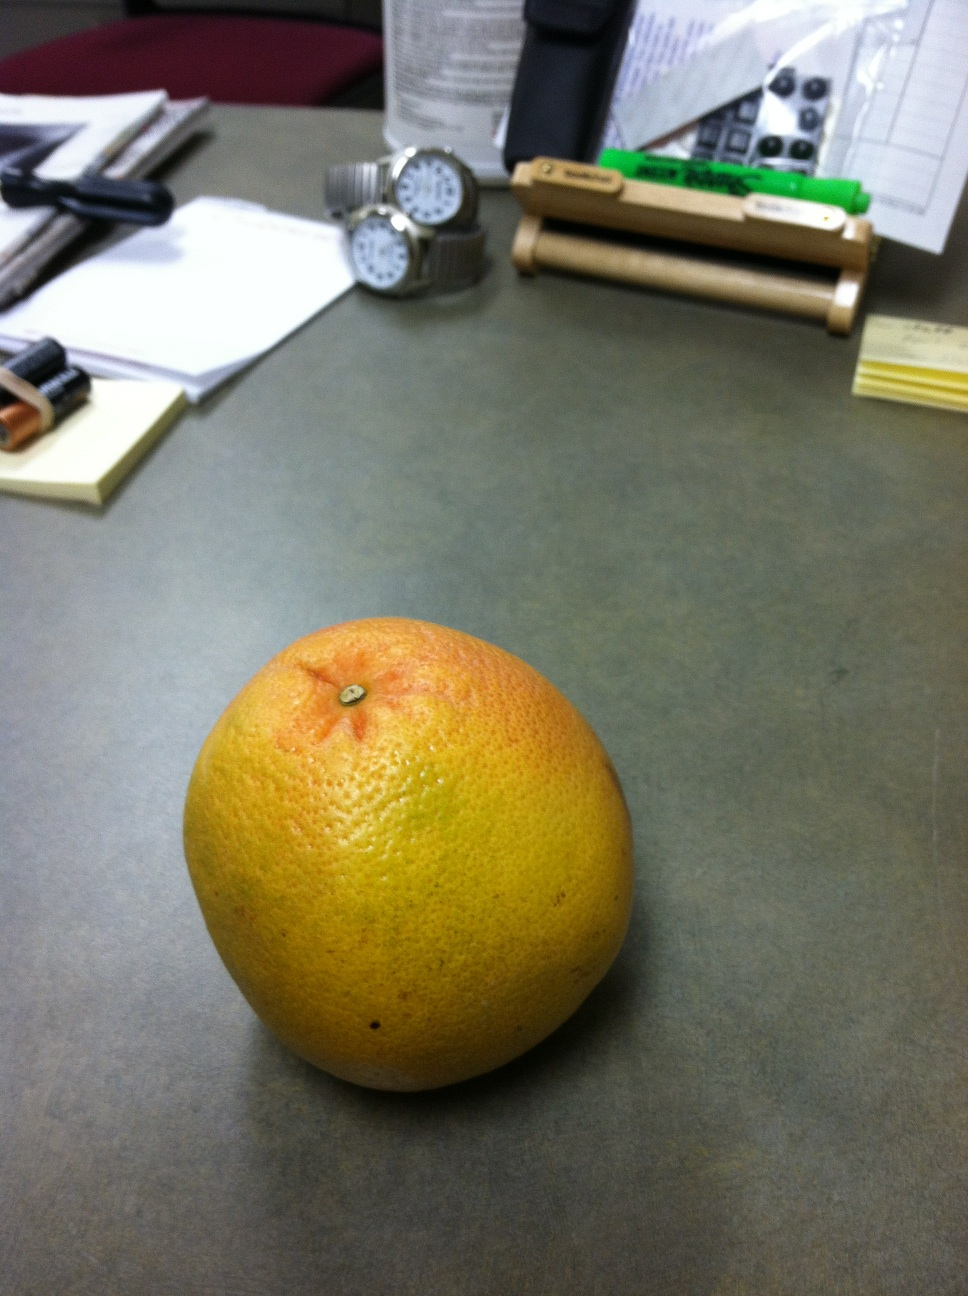Use the image to create another realistic scenario, this time focusing on the more personal and casual use of the desk's items. A college student has just returned from a run and plops down at their desk. They reach for the grapefruit, their go-to post-workout snack, and carefully peel it while browsing through emails on their laptop. The watches are set to remind them of an important virtual meeting with a study group later in the evening. Batteries scattered on the desk remind them to replace the ones in their gaming controller. The student jots down a quick reminder to buy more batteries on a sticky note, then leans back, enjoying the moment of quiet before diving into their study material for an upcoming exam. 